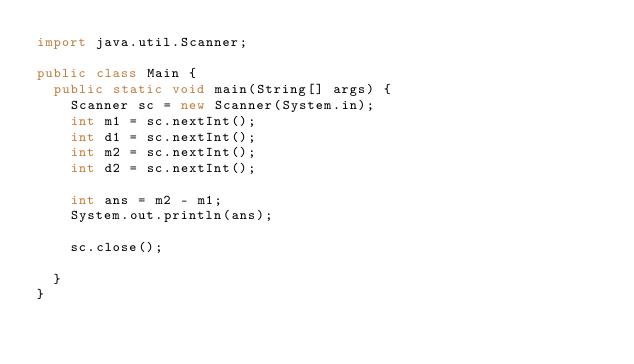<code> <loc_0><loc_0><loc_500><loc_500><_Java_>import java.util.Scanner;

public class Main {
	public static void main(String[] args) {
		Scanner sc = new Scanner(System.in);
		int m1 = sc.nextInt();
		int d1 = sc.nextInt();
		int m2 = sc.nextInt();
		int d2 = sc.nextInt();
		
		int ans = m2 - m1;
		System.out.println(ans);
		
		sc.close();
		
	}
}
</code> 